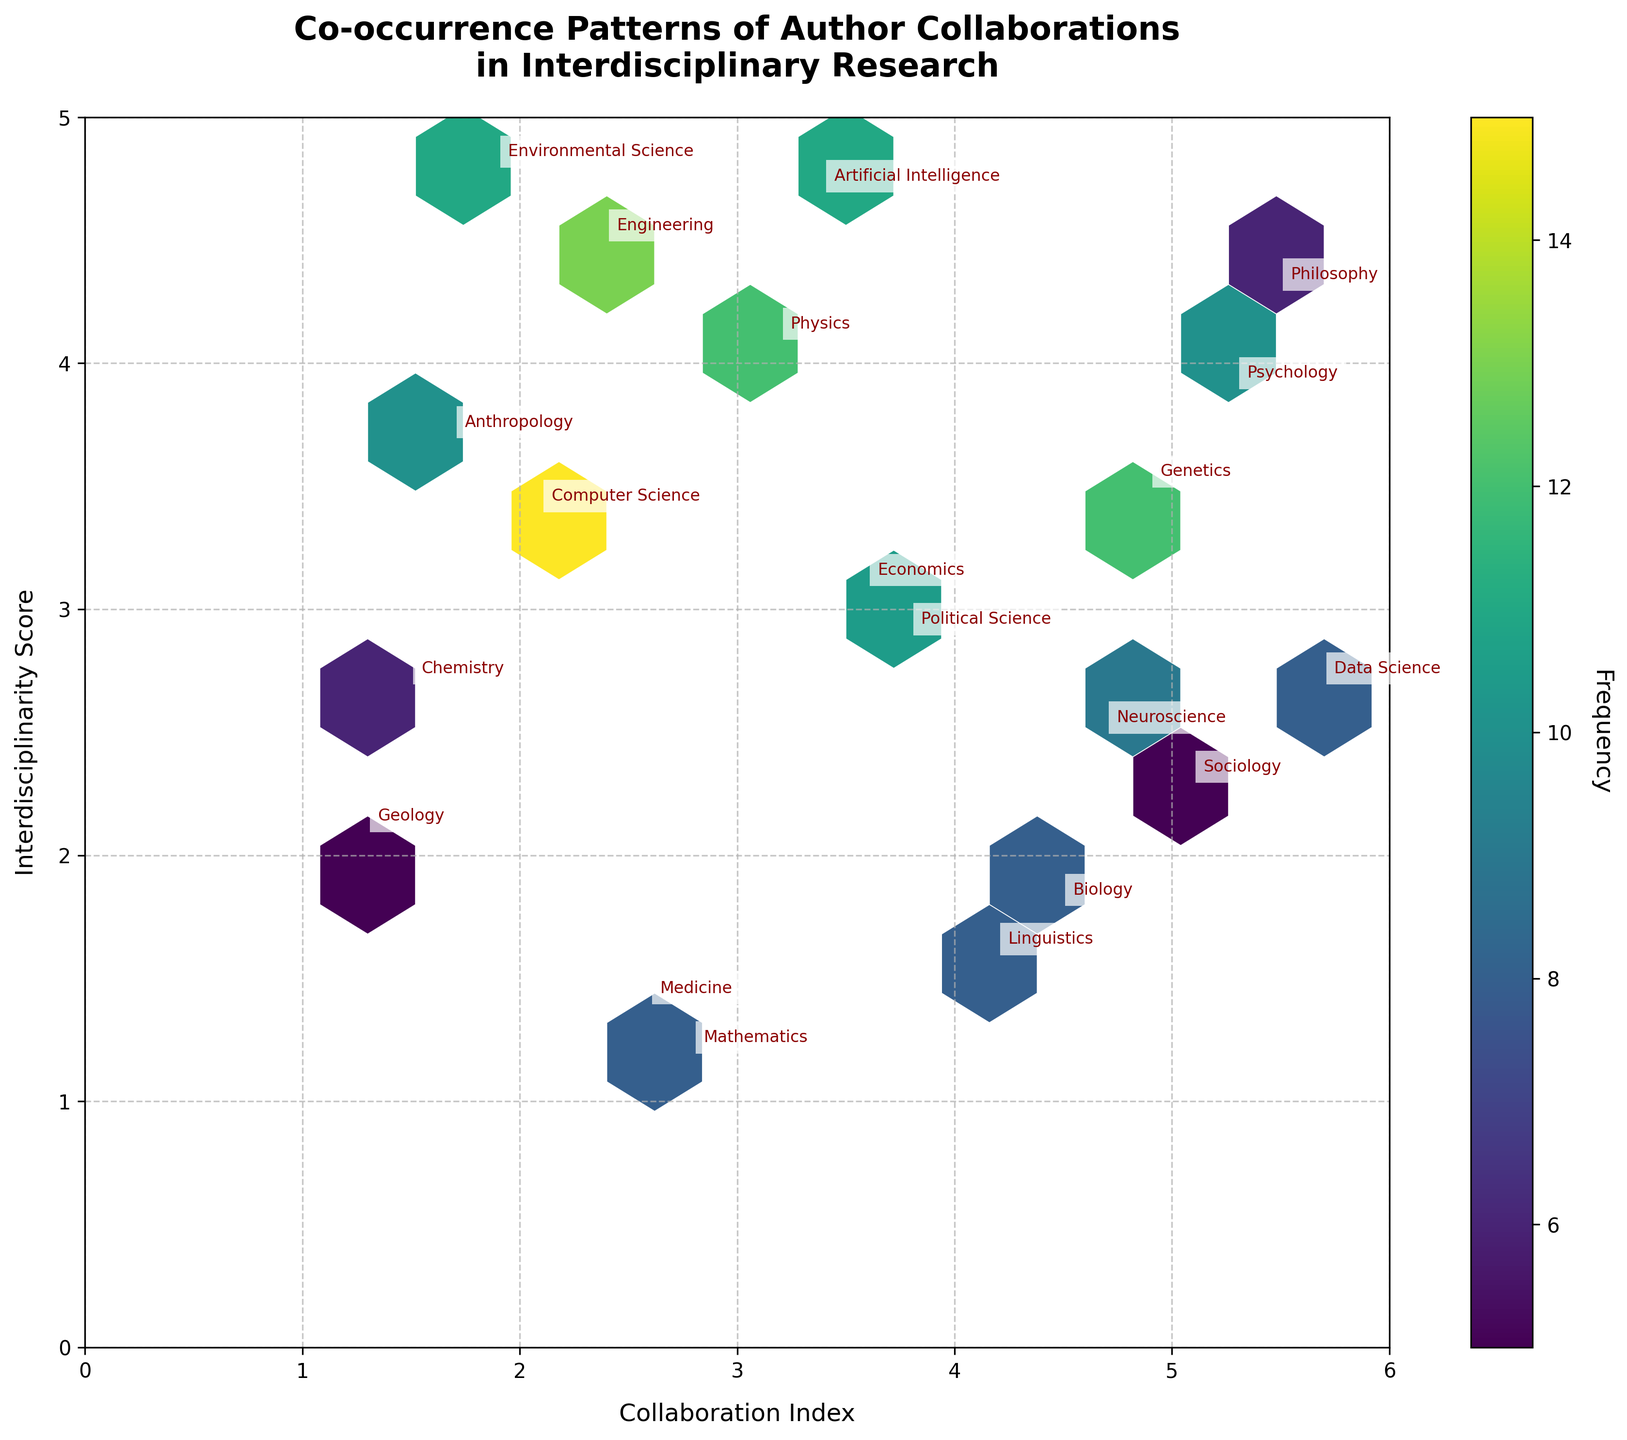How many data points are in the plot? The plot labels each data point with the corresponding discipline. By counting these labels, we can see how many data points are present in the plot.
Answer: 19 Which discipline has the highest frequency of author collaborations? The colorbar indicates that darker colors correspond to higher frequencies. The discipline labeled "Computer Science" is located at coordinates (2.1, 3.4) with the darkest hexagon, indicating the highest frequency of 15.
Answer: Computer Science What are the axes labels of the plot? The x-axis is labeled "Collaboration Index" and the y-axis is labeled "Interdisciplinarity Score". These labels are found at the bottom and left side of the plot respectively.
Answer: Collaboration Index and Interdisciplinarity Score Which two disciplines have the closest collaboration indices? By examining the x-coordinates of the disciplines, we find that "Genetics" (x=4.9) and "Neuroscience" (x=4.7) are closest to each other with a difference of 0.2.
Answer: Genetics and Neuroscience What is the range of the Interdisciplinarity Score axis? The y-axis has tick marks at regular intervals. From the limits shown on the figure, the minimum is 0 and the maximum is 5.
Answer: 0 to 5 Which discipline appears at the highest Interdisciplinarity Score? The "Environmental Science" discipline is positioned at (1.9, 4.8), the highest y-coordinate on the plot.
Answer: Environmental Science Are there any disciplines with the same frequency of author collaborations? By examining the labels and their corresponding colors or referenced values, we find that "Linguistics" and "Biology" both have a frequency of 8, similarly, "Philosophy" and "Chemistry" both have a frequency of 6.
Answer: Yes What is the mean Collaboration Index for all disciplines? Sum all the Collaboration Index values: \(2.1 + 4.5 + 3.2 + 1.5 + 5.3 + 2.8 + 4.7 + 1.9 + 3.6 + 5.1 + 2.4 + 4.2 + 1.7 + 3.8 + 5.5 + 2.6 + 4.9 + 1.3 + 3.4 + 5.7 = 69.6\). Divide by the number of data points (19): \(69.6 / 19 \approx 3.66\).
Answer: 3.66 Which hexagon color represents the most common frequency, and how many disciplines share this frequency? The color scale indicates that the lighter colors are more common. The frequency value of 8 appears in three disciplines: "Biology," "Linguistics," and "Data Science".
Answer: 8, three disciplines 